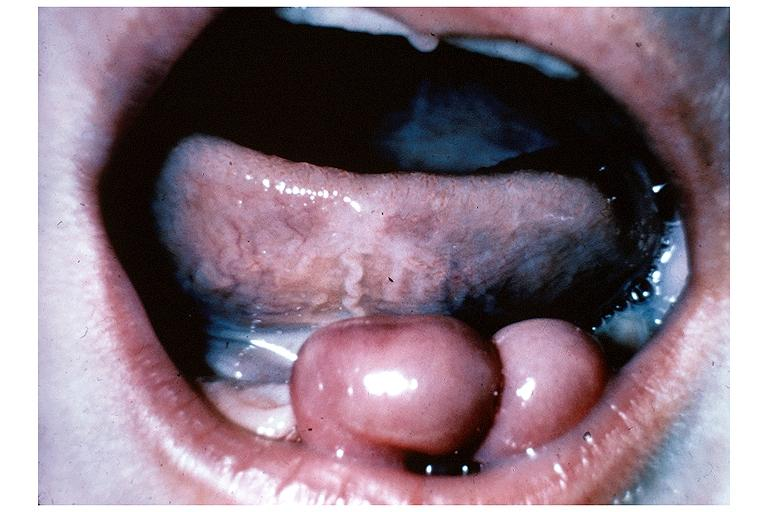what is present?
Answer the question using a single word or phrase. Oral 